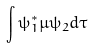Convert formula to latex. <formula><loc_0><loc_0><loc_500><loc_500>\int \psi _ { 1 } ^ { * } \mu \psi _ { 2 } d \tau</formula> 